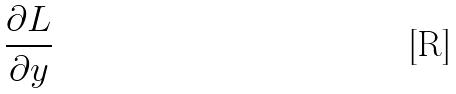<formula> <loc_0><loc_0><loc_500><loc_500>\frac { \partial L } { \partial y }</formula> 